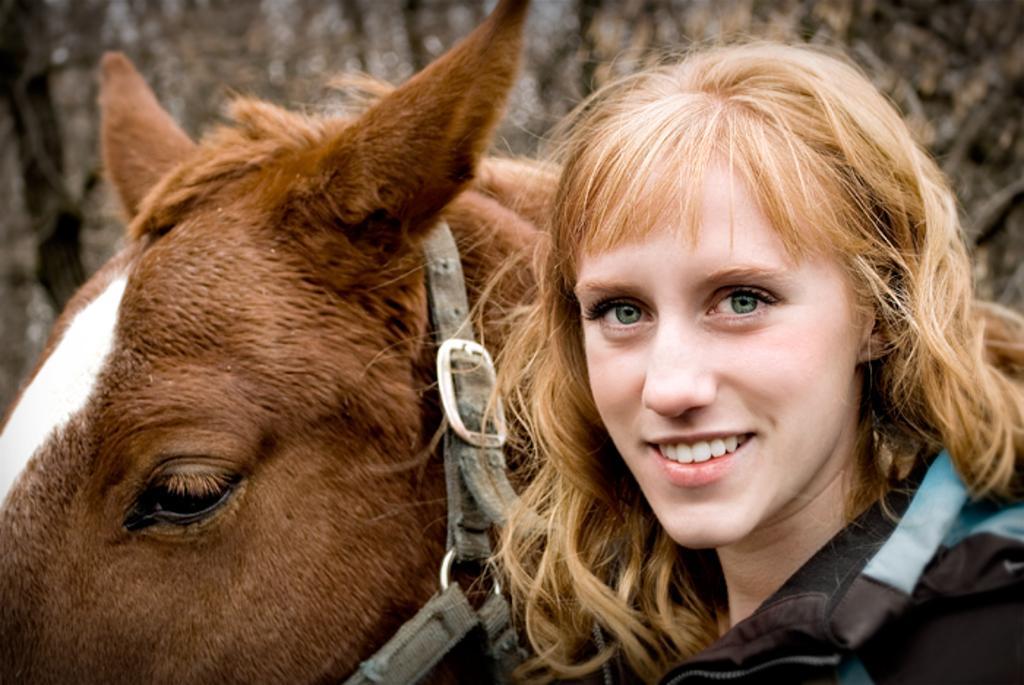Who is present in the image? There is a woman in the image. What is the woman standing beside? The woman is standing beside a brown color horse. How is the horse secured? The horse is tied with an ash color belt. What can be seen in the distance in the image? There are trees in the background of the image. Is there a writer in the image? There is no mention of a writer in the image; it features a woman standing beside a brown color horse. How many arms does the horse have in the image? Horses have four legs, not arms, and there is no indication of any additional limbs in the image. 